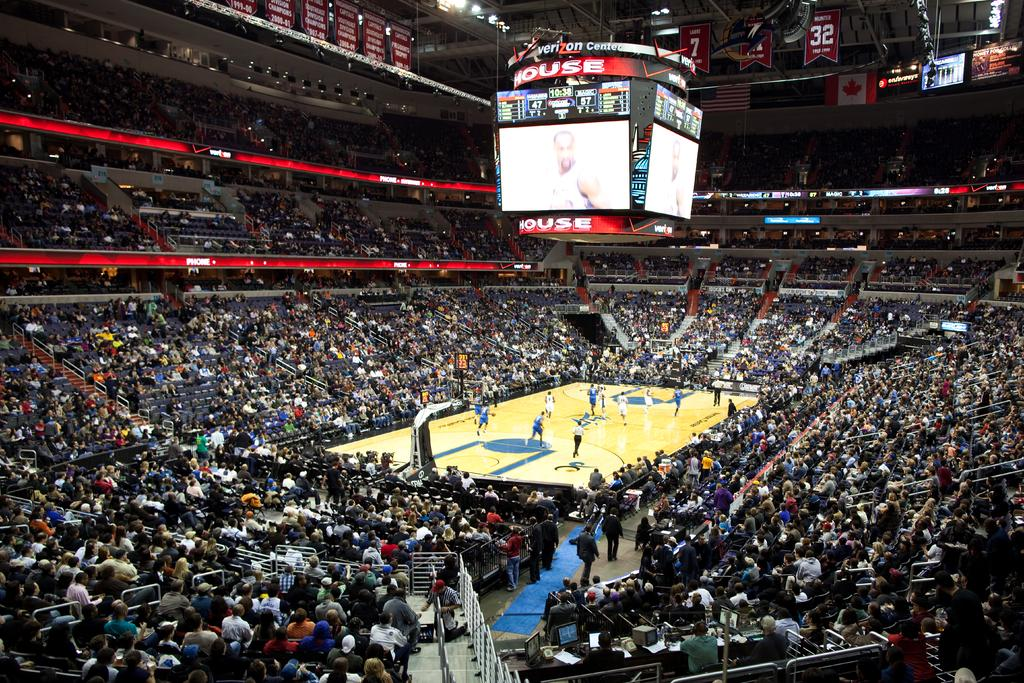<image>
Create a compact narrative representing the image presented. A full stadium at the Verizon Center watching a basketball game. 